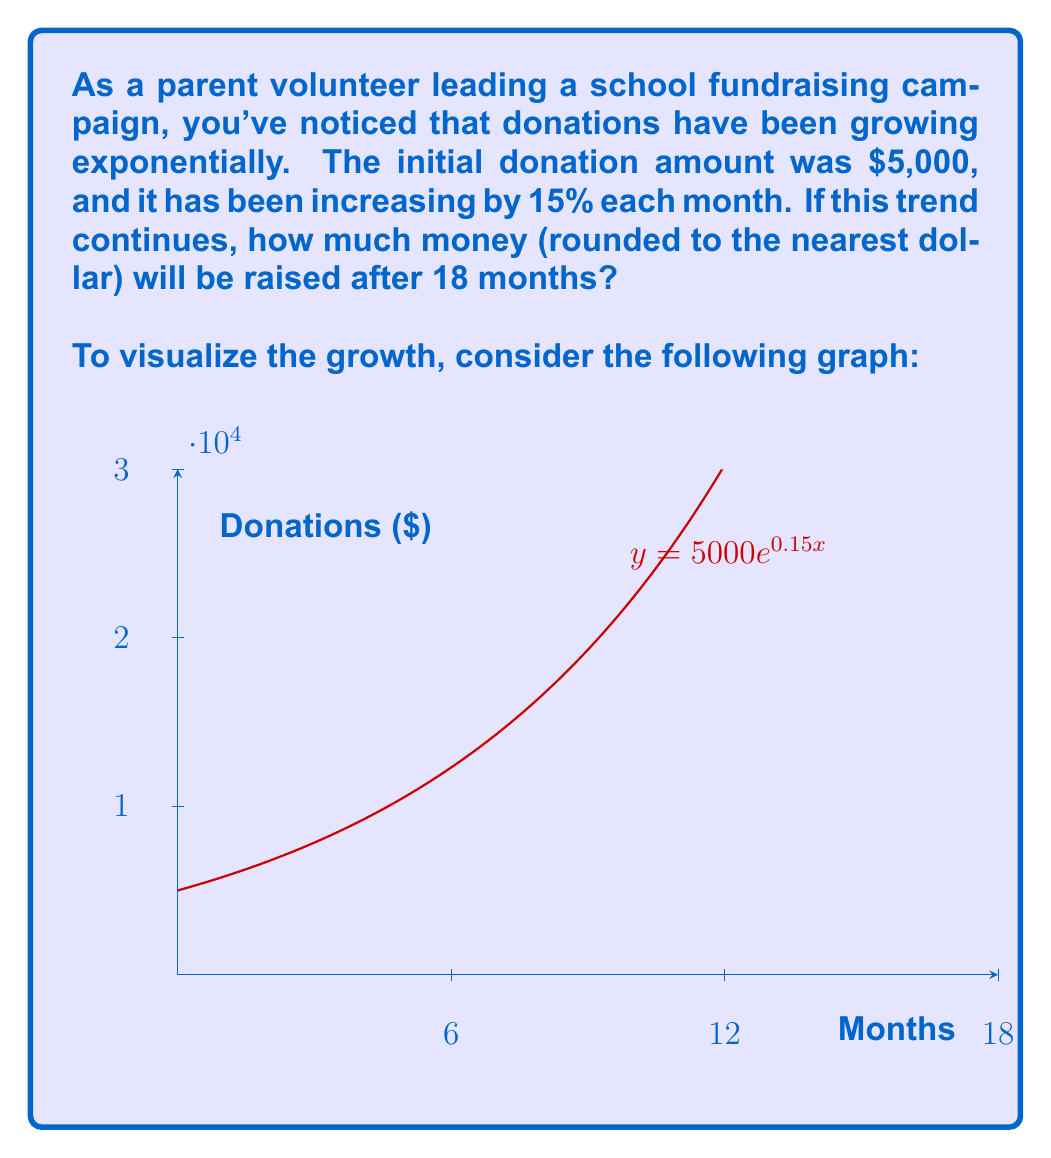Solve this math problem. Let's approach this step-by-step:

1) The exponential growth function is given by:
   $$A(t) = A_0 \cdot e^{rt}$$
   where $A(t)$ is the amount after time $t$, $A_0$ is the initial amount, $r$ is the growth rate, and $t$ is the time.

2) We know:
   - Initial amount, $A_0 = \$5,000$
   - Growth rate, $r = 15\% = 0.15$ (per month)
   - Time, $t = 18$ months

3) Plugging these values into the equation:
   $$A(18) = 5000 \cdot e^{0.15 \cdot 18}$$

4) Let's calculate:
   $$A(18) = 5000 \cdot e^{2.7}$$

5) Using a calculator:
   $$A(18) = 5000 \cdot 14.8797$$
   $$A(18) = 74,398.50$$

6) Rounding to the nearest dollar:
   $$A(18) \approx \$74,399$$

Therefore, after 18 months, the fundraising campaign will have raised approximately $74,399.
Answer: $74,399 